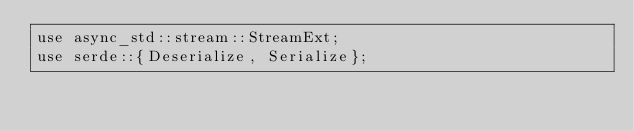Convert code to text. <code><loc_0><loc_0><loc_500><loc_500><_Rust_>use async_std::stream::StreamExt;
use serde::{Deserialize, Serialize};</code> 